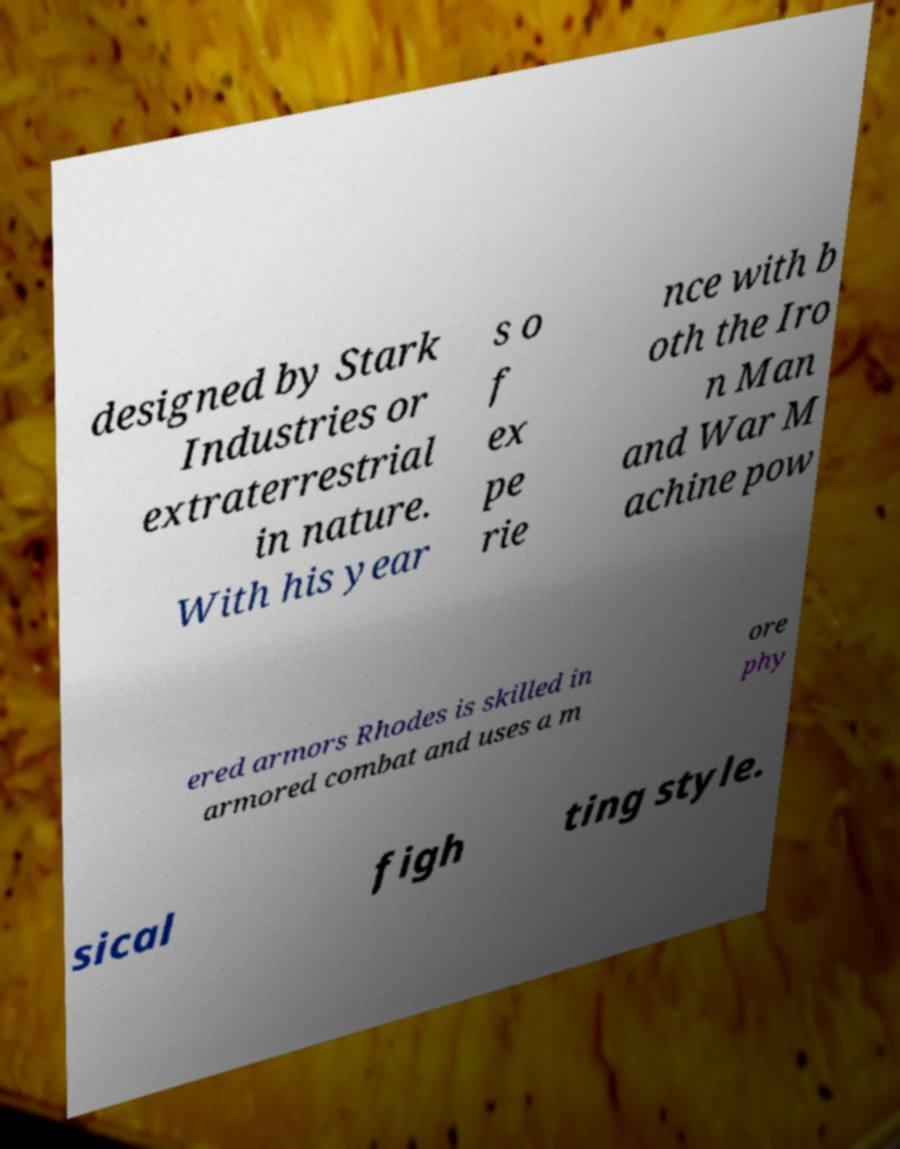I need the written content from this picture converted into text. Can you do that? designed by Stark Industries or extraterrestrial in nature. With his year s o f ex pe rie nce with b oth the Iro n Man and War M achine pow ered armors Rhodes is skilled in armored combat and uses a m ore phy sical figh ting style. 